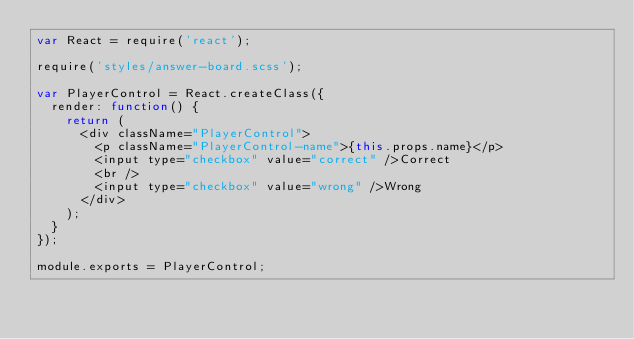<code> <loc_0><loc_0><loc_500><loc_500><_JavaScript_>var React = require('react');

require('styles/answer-board.scss');

var PlayerControl = React.createClass({
	render: function() {
		return (
			<div className="PlayerControl">
				<p className="PlayerControl-name">{this.props.name}</p>
				<input type="checkbox" value="correct" />Correct
				<br />
				<input type="checkbox" value="wrong" />Wrong
			</div>
		);
	}
});

module.exports = PlayerControl;
</code> 